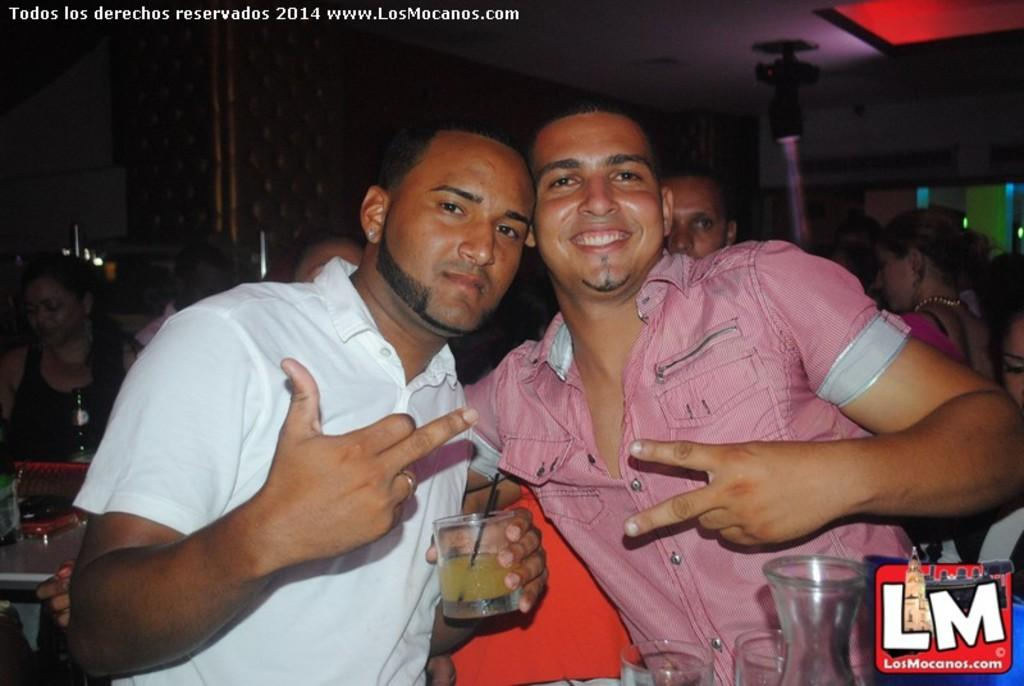How many people are in the room? There are people in the room, but the exact number is not specified. What is the person holding in their hand? The person is holding a glass with juice in it. Are there any other glasses visible in the room? Yes, there are additional glasses present. What time of day is depicted in the image? The time of day is not mentioned in the image or the provided facts, so it cannot be determined. What story is being told by the people in the room? There is no indication of a story being told in the image or the provided facts. 